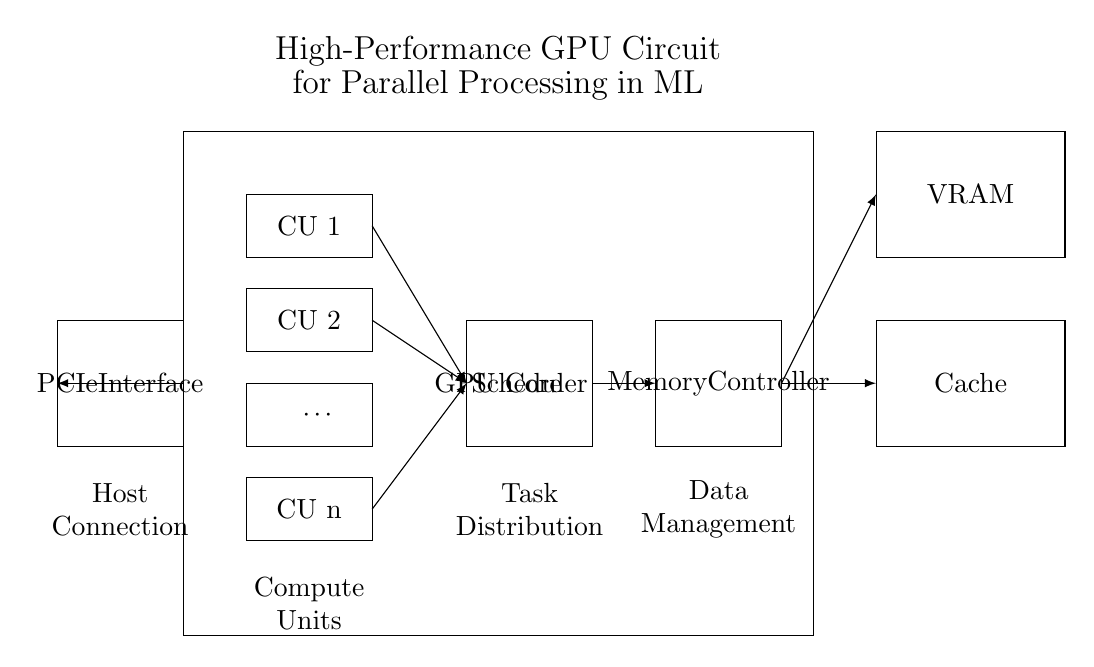What is the main component of this circuit? The main component visible in the circuit is the GPU Core, which is centrally located and labeled.
Answer: GPU Core How many Compute Units are represented? The circuit diagram indicates multiple Compute Units, with one explicitly labeled as "CU n", implying there are several units. The exact number isn't specified, but this usually denotes a scalable design.
Answer: n What role does the Memory Controller play? The Memory Controller manages data flow between the GPU Core and memory components, as depicted by its placement adjacent to both the Scheduler and VRAM.
Answer: Data Management Which component is responsible for distributing tasks? The Scheduler is positioned between the Compute Units and the Memory Controller, indicating it distributes tasks.
Answer: Scheduler What is the purpose of the PCIe Interface? The PCIe Interface connects the GPU to the host system, facilitating communication for data transfer, as shown on the left side of the diagram.
Answer: Host Connection What is the function of the Cache in this circuit? The Cache stores frequently accessed data to improve performance; its placement next to VRAM suggests it optimizes data access for the Compute Units.
Answer: Temporary storage How does the Scheduler interact with the Compute Units? The Scheduler receives input from all Compute Units (indicated by arrows pointing towards it) to effectively manage and distribute workloads across the available processing power.
Answer: Task Distribution 